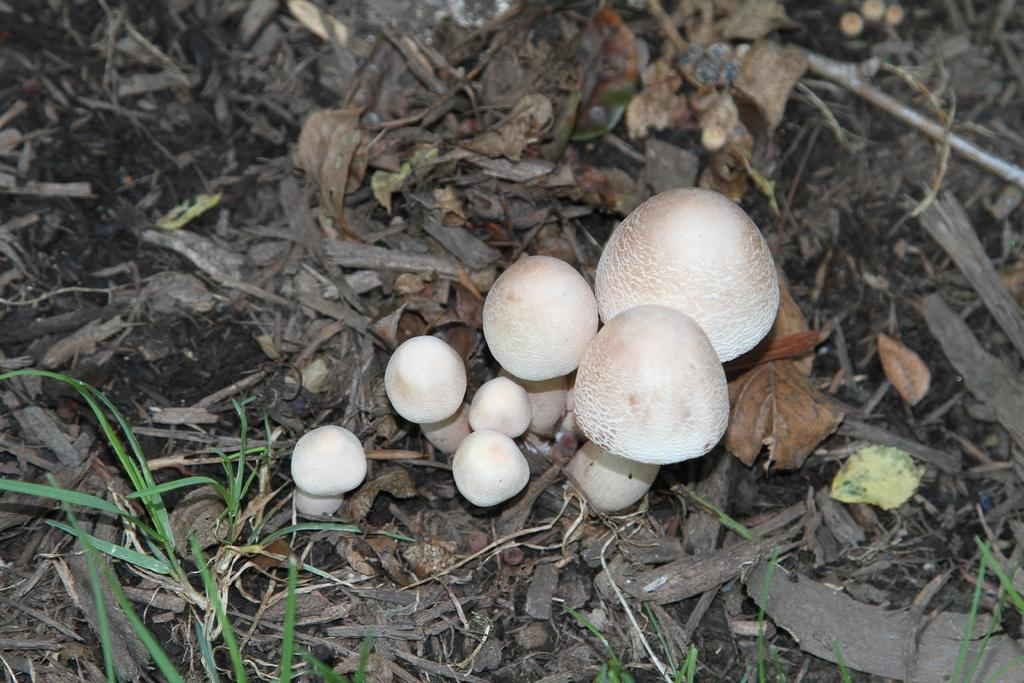What type of fungi can be seen in the image? There are mushrooms in the image. What type of plant material is present in the image? There are dried leaves in the image. What type of vegetation is visible in the image? There is grass in the image. Can you see any cobwebs in the image? There is no mention of cobwebs in the image, so it cannot be determined if any are present. How many mushrooms can be seen lifting the dried leaves in the image? Mushrooms do not have the ability to lift objects, so this scenario cannot be observed in the image. 